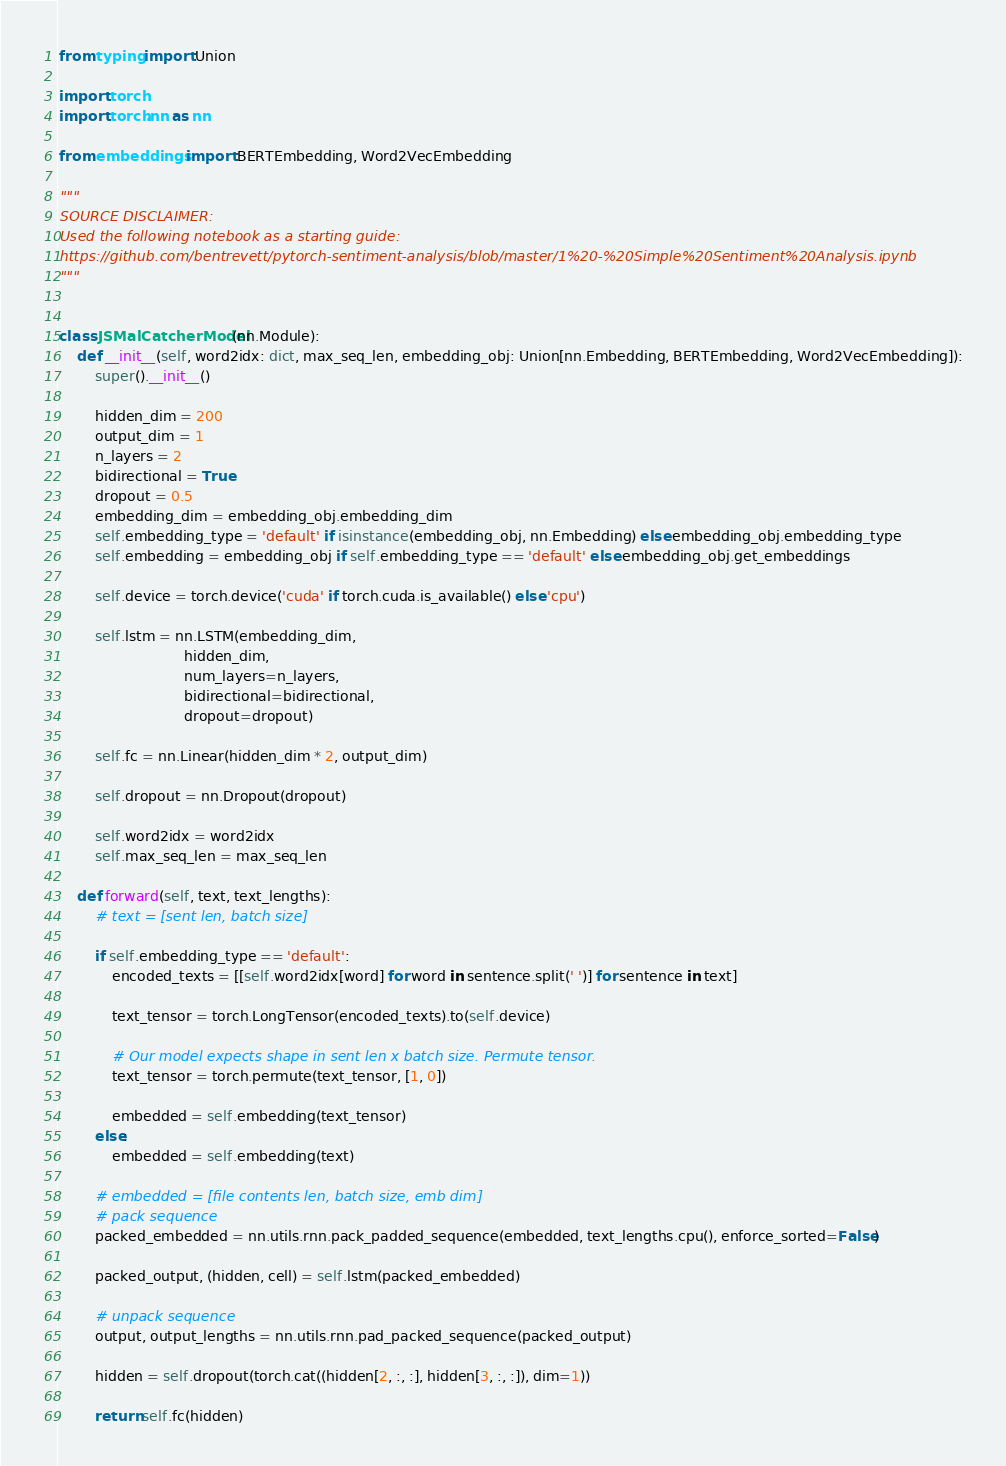Convert code to text. <code><loc_0><loc_0><loc_500><loc_500><_Python_>from typing import Union

import torch
import torch.nn as nn

from embeddings import BERTEmbedding, Word2VecEmbedding

"""
SOURCE DISCLAIMER:
Used the following notebook as a starting guide:
https://github.com/bentrevett/pytorch-sentiment-analysis/blob/master/1%20-%20Simple%20Sentiment%20Analysis.ipynb
"""


class JSMalCatcherModel(nn.Module):
    def __init__(self, word2idx: dict, max_seq_len, embedding_obj: Union[nn.Embedding, BERTEmbedding, Word2VecEmbedding]):
        super().__init__()

        hidden_dim = 200
        output_dim = 1
        n_layers = 2
        bidirectional = True
        dropout = 0.5
        embedding_dim = embedding_obj.embedding_dim
        self.embedding_type = 'default' if isinstance(embedding_obj, nn.Embedding) else embedding_obj.embedding_type
        self.embedding = embedding_obj if self.embedding_type == 'default' else embedding_obj.get_embeddings

        self.device = torch.device('cuda' if torch.cuda.is_available() else 'cpu')

        self.lstm = nn.LSTM(embedding_dim,
                            hidden_dim,
                            num_layers=n_layers,
                            bidirectional=bidirectional,
                            dropout=dropout)

        self.fc = nn.Linear(hidden_dim * 2, output_dim)

        self.dropout = nn.Dropout(dropout)

        self.word2idx = word2idx
        self.max_seq_len = max_seq_len

    def forward(self, text, text_lengths):
        # text = [sent len, batch size]

        if self.embedding_type == 'default':
            encoded_texts = [[self.word2idx[word] for word in sentence.split(' ')] for sentence in text]

            text_tensor = torch.LongTensor(encoded_texts).to(self.device)

            # Our model expects shape in sent len x batch size. Permute tensor.
            text_tensor = torch.permute(text_tensor, [1, 0])

            embedded = self.embedding(text_tensor)
        else:
            embedded = self.embedding(text)

        # embedded = [file contents len, batch size, emb dim]
        # pack sequence
        packed_embedded = nn.utils.rnn.pack_padded_sequence(embedded, text_lengths.cpu(), enforce_sorted=False)

        packed_output, (hidden, cell) = self.lstm(packed_embedded)

        # unpack sequence
        output, output_lengths = nn.utils.rnn.pad_packed_sequence(packed_output)

        hidden = self.dropout(torch.cat((hidden[2, :, :], hidden[3, :, :]), dim=1))

        return self.fc(hidden)
</code> 